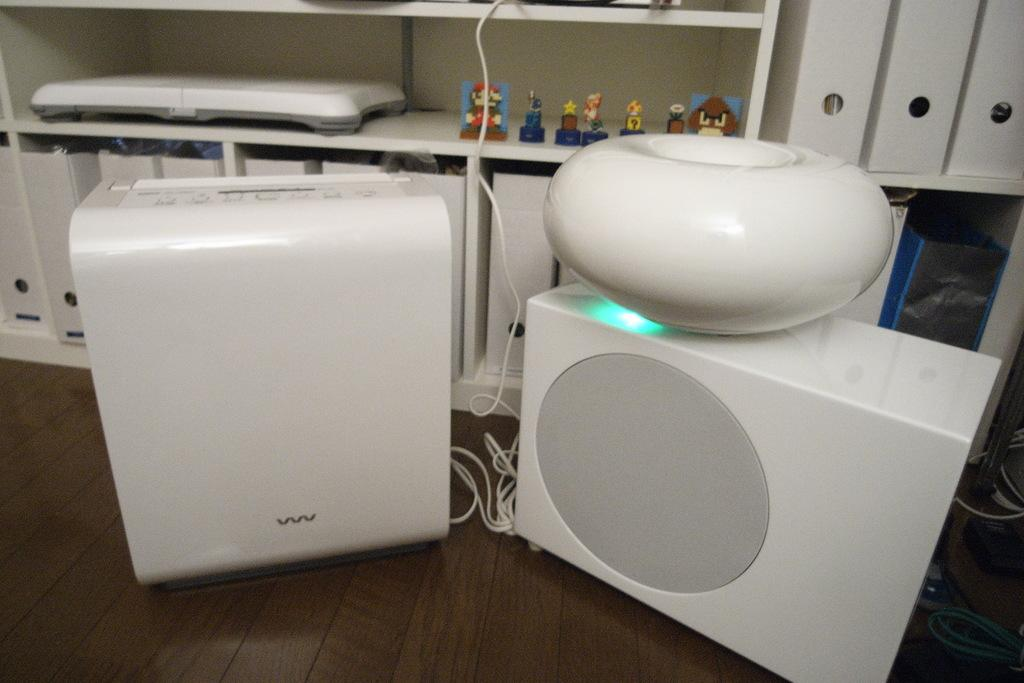What is the main object in the center of the image? There is a dehumidifier in the center of the image. Can you describe the object in more detail? The dehumidifier is a device used to remove moisture from the air. What type of fear is depicted in the image? There is no fear depicted in the image; it features a dehumidifier in the center. What kind of building is hosting the party in the image? There is no building or party present in the image; it only shows a dehumidifier. 